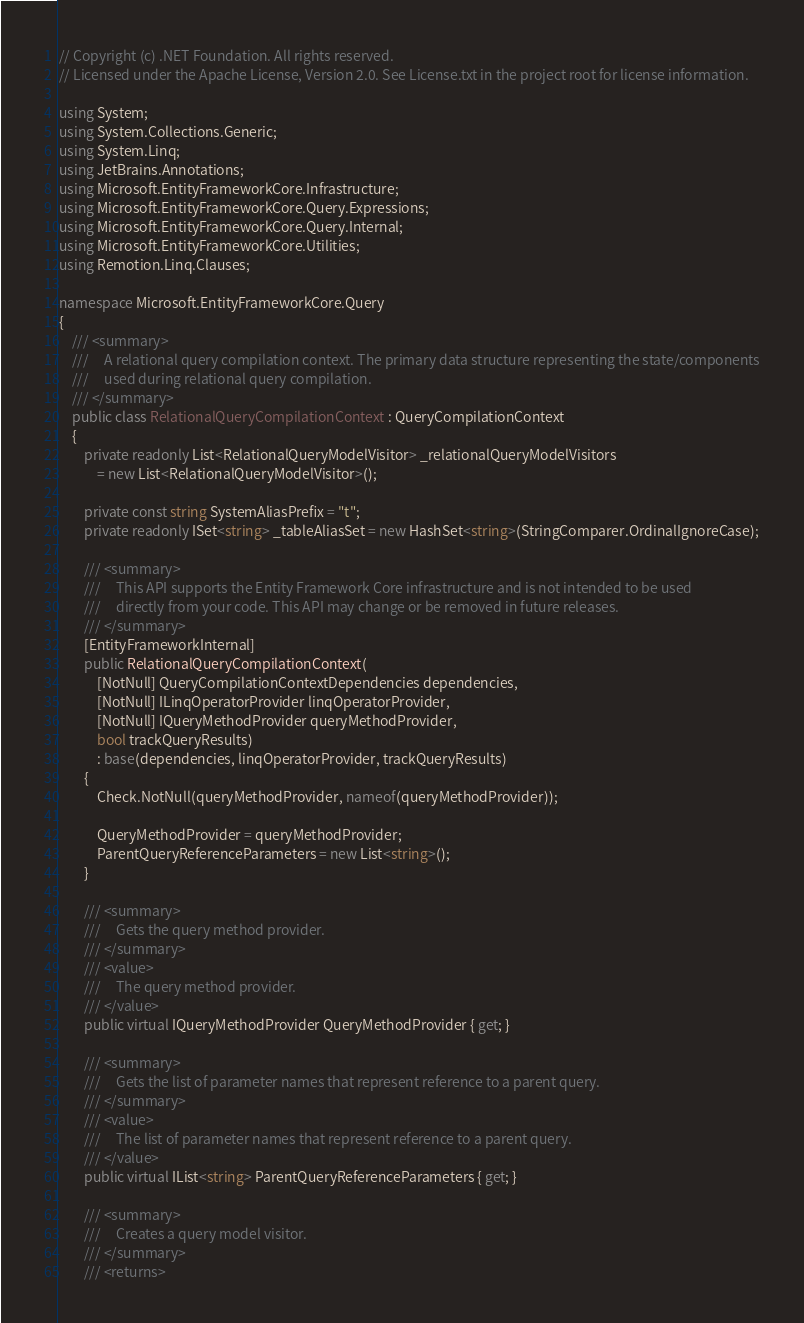Convert code to text. <code><loc_0><loc_0><loc_500><loc_500><_C#_>// Copyright (c) .NET Foundation. All rights reserved.
// Licensed under the Apache License, Version 2.0. See License.txt in the project root for license information.

using System;
using System.Collections.Generic;
using System.Linq;
using JetBrains.Annotations;
using Microsoft.EntityFrameworkCore.Infrastructure;
using Microsoft.EntityFrameworkCore.Query.Expressions;
using Microsoft.EntityFrameworkCore.Query.Internal;
using Microsoft.EntityFrameworkCore.Utilities;
using Remotion.Linq.Clauses;

namespace Microsoft.EntityFrameworkCore.Query
{
    /// <summary>
    ///     A relational query compilation context. The primary data structure representing the state/components
    ///     used during relational query compilation.
    /// </summary>
    public class RelationalQueryCompilationContext : QueryCompilationContext
    {
        private readonly List<RelationalQueryModelVisitor> _relationalQueryModelVisitors
            = new List<RelationalQueryModelVisitor>();

        private const string SystemAliasPrefix = "t";
        private readonly ISet<string> _tableAliasSet = new HashSet<string>(StringComparer.OrdinalIgnoreCase);

        /// <summary>
        ///     This API supports the Entity Framework Core infrastructure and is not intended to be used
        ///     directly from your code. This API may change or be removed in future releases.
        /// </summary>
        [EntityFrameworkInternal]
        public RelationalQueryCompilationContext(
            [NotNull] QueryCompilationContextDependencies dependencies,
            [NotNull] ILinqOperatorProvider linqOperatorProvider,
            [NotNull] IQueryMethodProvider queryMethodProvider,
            bool trackQueryResults)
            : base(dependencies, linqOperatorProvider, trackQueryResults)
        {
            Check.NotNull(queryMethodProvider, nameof(queryMethodProvider));

            QueryMethodProvider = queryMethodProvider;
            ParentQueryReferenceParameters = new List<string>();
        }

        /// <summary>
        ///     Gets the query method provider.
        /// </summary>
        /// <value>
        ///     The query method provider.
        /// </value>
        public virtual IQueryMethodProvider QueryMethodProvider { get; }

        /// <summary>
        ///     Gets the list of parameter names that represent reference to a parent query.
        /// </summary>
        /// <value>
        ///     The list of parameter names that represent reference to a parent query.
        /// </value>
        public virtual IList<string> ParentQueryReferenceParameters { get; }

        /// <summary>
        ///     Creates a query model visitor.
        /// </summary>
        /// <returns></code> 